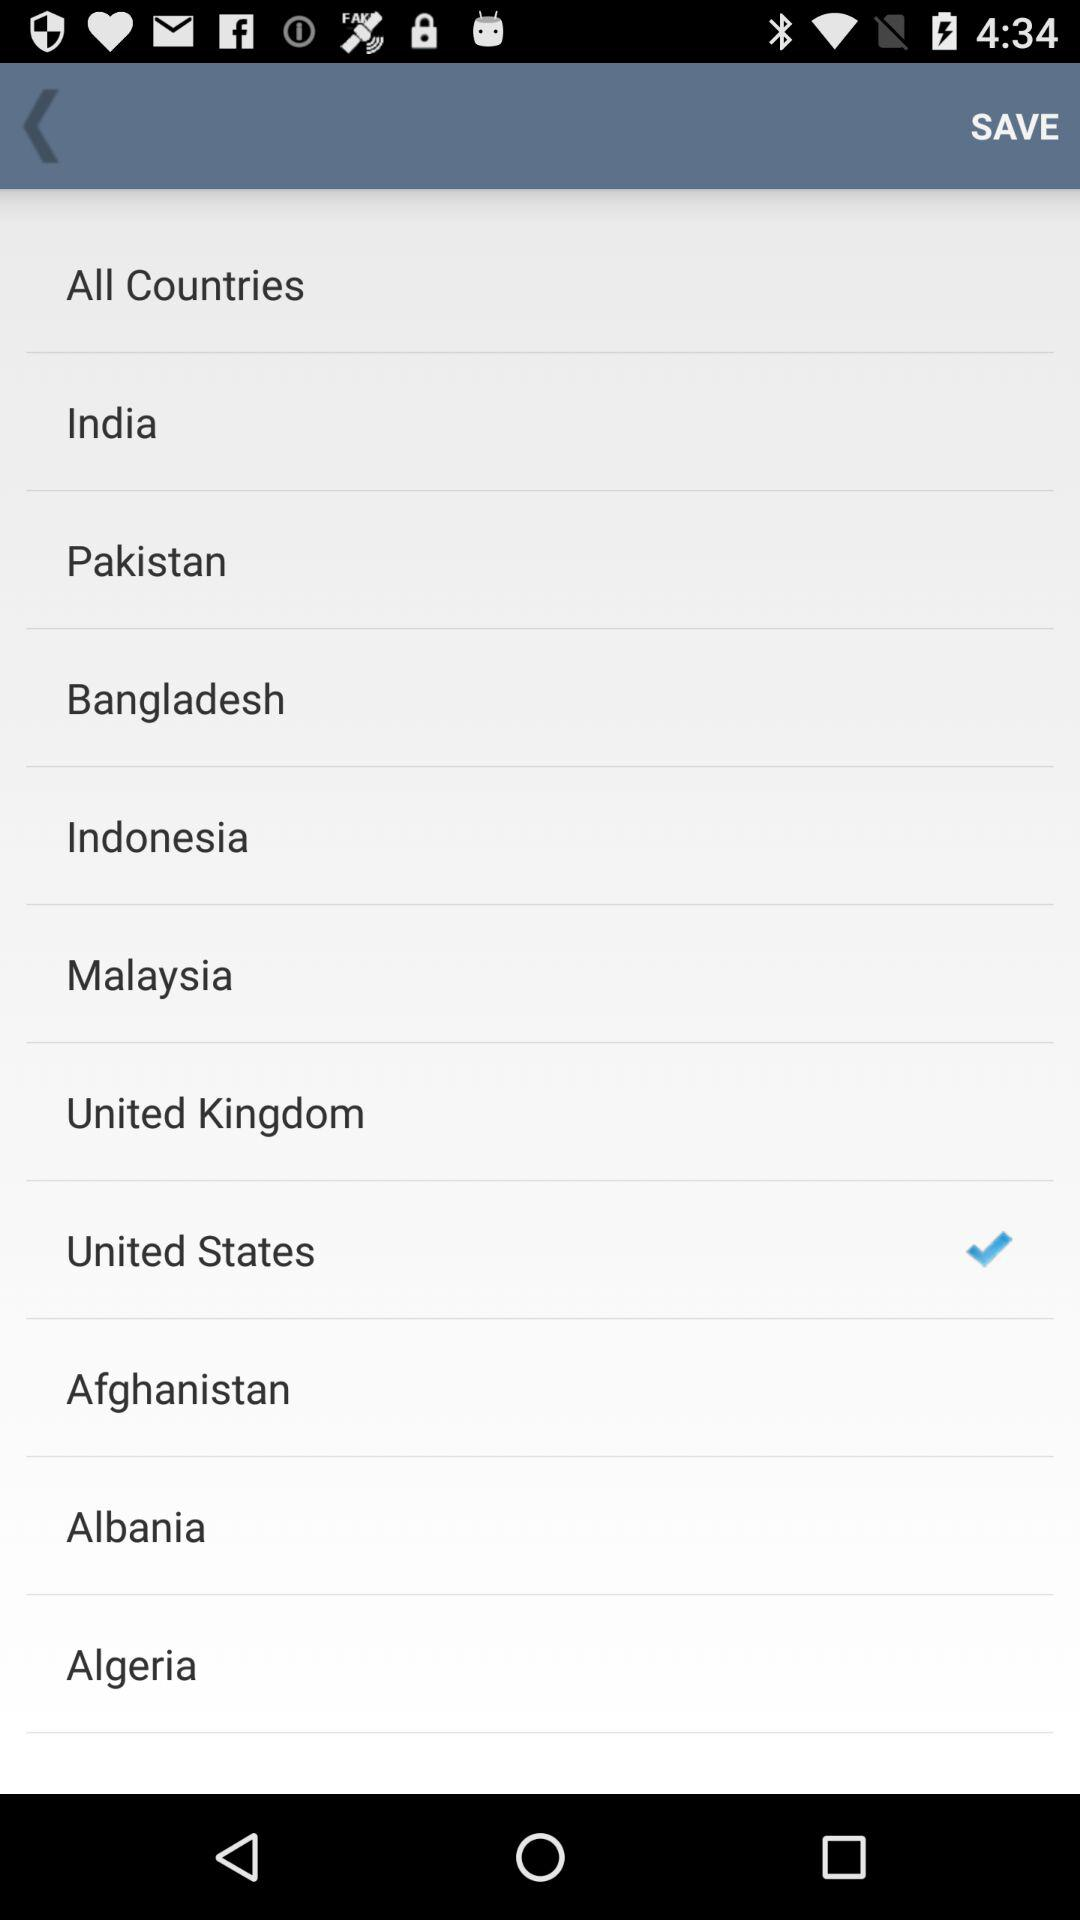How many countries are checked?
Answer the question using a single word or phrase. 1 